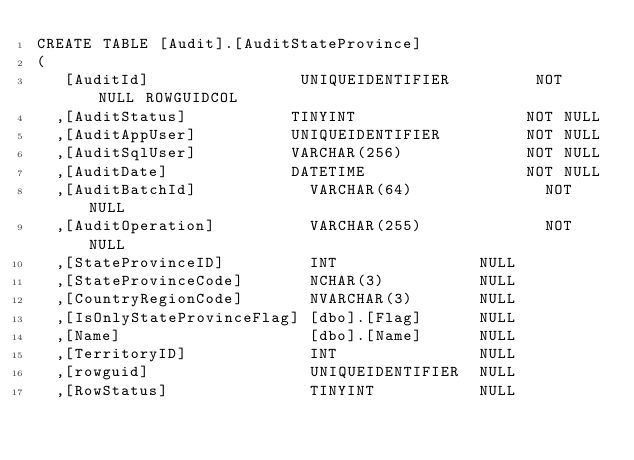<code> <loc_0><loc_0><loc_500><loc_500><_SQL_>CREATE TABLE [Audit].[AuditStateProvince]
(
   [AuditId]                UNIQUEIDENTIFIER         NOT NULL ROWGUIDCOL
  ,[AuditStatus]           TINYINT                  NOT NULL
  ,[AuditAppUser]          UNIQUEIDENTIFIER         NOT NULL
  ,[AuditSqlUser]          VARCHAR(256)             NOT NULL
  ,[AuditDate]             DATETIME                 NOT NULL
  ,[AuditBatchId]            VARCHAR(64)              NOT NULL
  ,[AuditOperation]          VARCHAR(255)             NOT NULL
  ,[StateProvinceID]         INT               NULL
  ,[StateProvinceCode]       NCHAR(3)          NULL
  ,[CountryRegionCode]       NVARCHAR(3)       NULL
  ,[IsOnlyStateProvinceFlag] [dbo].[Flag]      NULL
  ,[Name]                    [dbo].[Name]      NULL
  ,[TerritoryID]             INT               NULL
  ,[rowguid]                 UNIQUEIDENTIFIER  NULL
  ,[RowStatus]               TINYINT           NULL</code> 